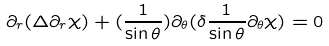Convert formula to latex. <formula><loc_0><loc_0><loc_500><loc_500>\partial _ { r } ( \Delta \partial _ { r } \chi ) + ( \frac { 1 } { \sin \theta } ) \partial _ { \theta } ( \delta \frac { 1 } { \sin \theta } \partial _ { \theta } \chi ) = 0</formula> 